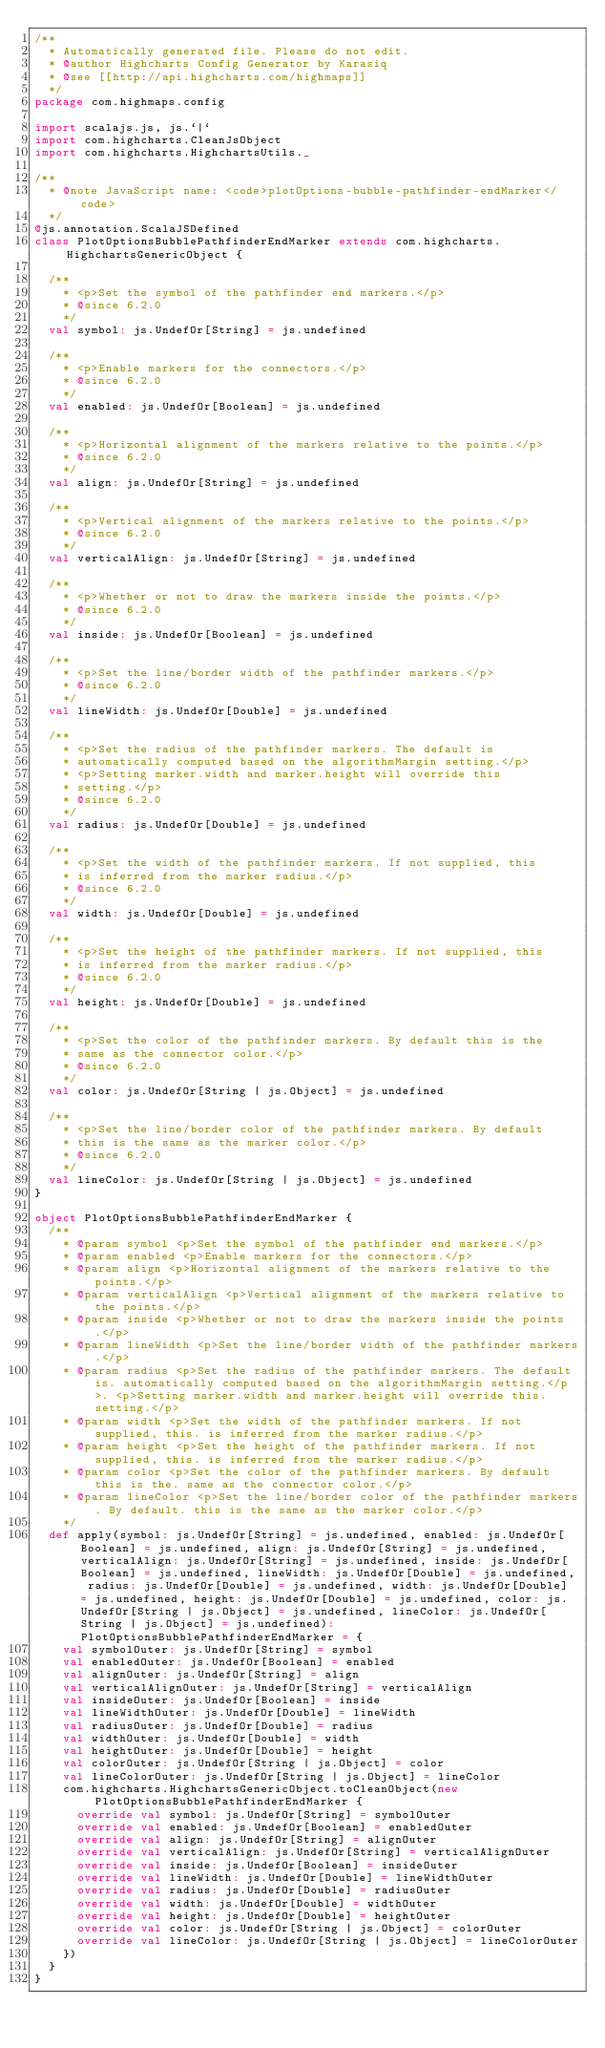Convert code to text. <code><loc_0><loc_0><loc_500><loc_500><_Scala_>/**
  * Automatically generated file. Please do not edit.
  * @author Highcharts Config Generator by Karasiq
  * @see [[http://api.highcharts.com/highmaps]]
  */
package com.highmaps.config

import scalajs.js, js.`|`
import com.highcharts.CleanJsObject
import com.highcharts.HighchartsUtils._

/**
  * @note JavaScript name: <code>plotOptions-bubble-pathfinder-endMarker</code>
  */
@js.annotation.ScalaJSDefined
class PlotOptionsBubblePathfinderEndMarker extends com.highcharts.HighchartsGenericObject {

  /**
    * <p>Set the symbol of the pathfinder end markers.</p>
    * @since 6.2.0
    */
  val symbol: js.UndefOr[String] = js.undefined

  /**
    * <p>Enable markers for the connectors.</p>
    * @since 6.2.0
    */
  val enabled: js.UndefOr[Boolean] = js.undefined

  /**
    * <p>Horizontal alignment of the markers relative to the points.</p>
    * @since 6.2.0
    */
  val align: js.UndefOr[String] = js.undefined

  /**
    * <p>Vertical alignment of the markers relative to the points.</p>
    * @since 6.2.0
    */
  val verticalAlign: js.UndefOr[String] = js.undefined

  /**
    * <p>Whether or not to draw the markers inside the points.</p>
    * @since 6.2.0
    */
  val inside: js.UndefOr[Boolean] = js.undefined

  /**
    * <p>Set the line/border width of the pathfinder markers.</p>
    * @since 6.2.0
    */
  val lineWidth: js.UndefOr[Double] = js.undefined

  /**
    * <p>Set the radius of the pathfinder markers. The default is
    * automatically computed based on the algorithmMargin setting.</p>
    * <p>Setting marker.width and marker.height will override this
    * setting.</p>
    * @since 6.2.0
    */
  val radius: js.UndefOr[Double] = js.undefined

  /**
    * <p>Set the width of the pathfinder markers. If not supplied, this
    * is inferred from the marker radius.</p>
    * @since 6.2.0
    */
  val width: js.UndefOr[Double] = js.undefined

  /**
    * <p>Set the height of the pathfinder markers. If not supplied, this
    * is inferred from the marker radius.</p>
    * @since 6.2.0
    */
  val height: js.UndefOr[Double] = js.undefined

  /**
    * <p>Set the color of the pathfinder markers. By default this is the
    * same as the connector color.</p>
    * @since 6.2.0
    */
  val color: js.UndefOr[String | js.Object] = js.undefined

  /**
    * <p>Set the line/border color of the pathfinder markers. By default
    * this is the same as the marker color.</p>
    * @since 6.2.0
    */
  val lineColor: js.UndefOr[String | js.Object] = js.undefined
}

object PlotOptionsBubblePathfinderEndMarker {
  /**
    * @param symbol <p>Set the symbol of the pathfinder end markers.</p>
    * @param enabled <p>Enable markers for the connectors.</p>
    * @param align <p>Horizontal alignment of the markers relative to the points.</p>
    * @param verticalAlign <p>Vertical alignment of the markers relative to the points.</p>
    * @param inside <p>Whether or not to draw the markers inside the points.</p>
    * @param lineWidth <p>Set the line/border width of the pathfinder markers.</p>
    * @param radius <p>Set the radius of the pathfinder markers. The default is. automatically computed based on the algorithmMargin setting.</p>. <p>Setting marker.width and marker.height will override this. setting.</p>
    * @param width <p>Set the width of the pathfinder markers. If not supplied, this. is inferred from the marker radius.</p>
    * @param height <p>Set the height of the pathfinder markers. If not supplied, this. is inferred from the marker radius.</p>
    * @param color <p>Set the color of the pathfinder markers. By default this is the. same as the connector color.</p>
    * @param lineColor <p>Set the line/border color of the pathfinder markers. By default. this is the same as the marker color.</p>
    */
  def apply(symbol: js.UndefOr[String] = js.undefined, enabled: js.UndefOr[Boolean] = js.undefined, align: js.UndefOr[String] = js.undefined, verticalAlign: js.UndefOr[String] = js.undefined, inside: js.UndefOr[Boolean] = js.undefined, lineWidth: js.UndefOr[Double] = js.undefined, radius: js.UndefOr[Double] = js.undefined, width: js.UndefOr[Double] = js.undefined, height: js.UndefOr[Double] = js.undefined, color: js.UndefOr[String | js.Object] = js.undefined, lineColor: js.UndefOr[String | js.Object] = js.undefined): PlotOptionsBubblePathfinderEndMarker = {
    val symbolOuter: js.UndefOr[String] = symbol
    val enabledOuter: js.UndefOr[Boolean] = enabled
    val alignOuter: js.UndefOr[String] = align
    val verticalAlignOuter: js.UndefOr[String] = verticalAlign
    val insideOuter: js.UndefOr[Boolean] = inside
    val lineWidthOuter: js.UndefOr[Double] = lineWidth
    val radiusOuter: js.UndefOr[Double] = radius
    val widthOuter: js.UndefOr[Double] = width
    val heightOuter: js.UndefOr[Double] = height
    val colorOuter: js.UndefOr[String | js.Object] = color
    val lineColorOuter: js.UndefOr[String | js.Object] = lineColor
    com.highcharts.HighchartsGenericObject.toCleanObject(new PlotOptionsBubblePathfinderEndMarker {
      override val symbol: js.UndefOr[String] = symbolOuter
      override val enabled: js.UndefOr[Boolean] = enabledOuter
      override val align: js.UndefOr[String] = alignOuter
      override val verticalAlign: js.UndefOr[String] = verticalAlignOuter
      override val inside: js.UndefOr[Boolean] = insideOuter
      override val lineWidth: js.UndefOr[Double] = lineWidthOuter
      override val radius: js.UndefOr[Double] = radiusOuter
      override val width: js.UndefOr[Double] = widthOuter
      override val height: js.UndefOr[Double] = heightOuter
      override val color: js.UndefOr[String | js.Object] = colorOuter
      override val lineColor: js.UndefOr[String | js.Object] = lineColorOuter
    })
  }
}
</code> 